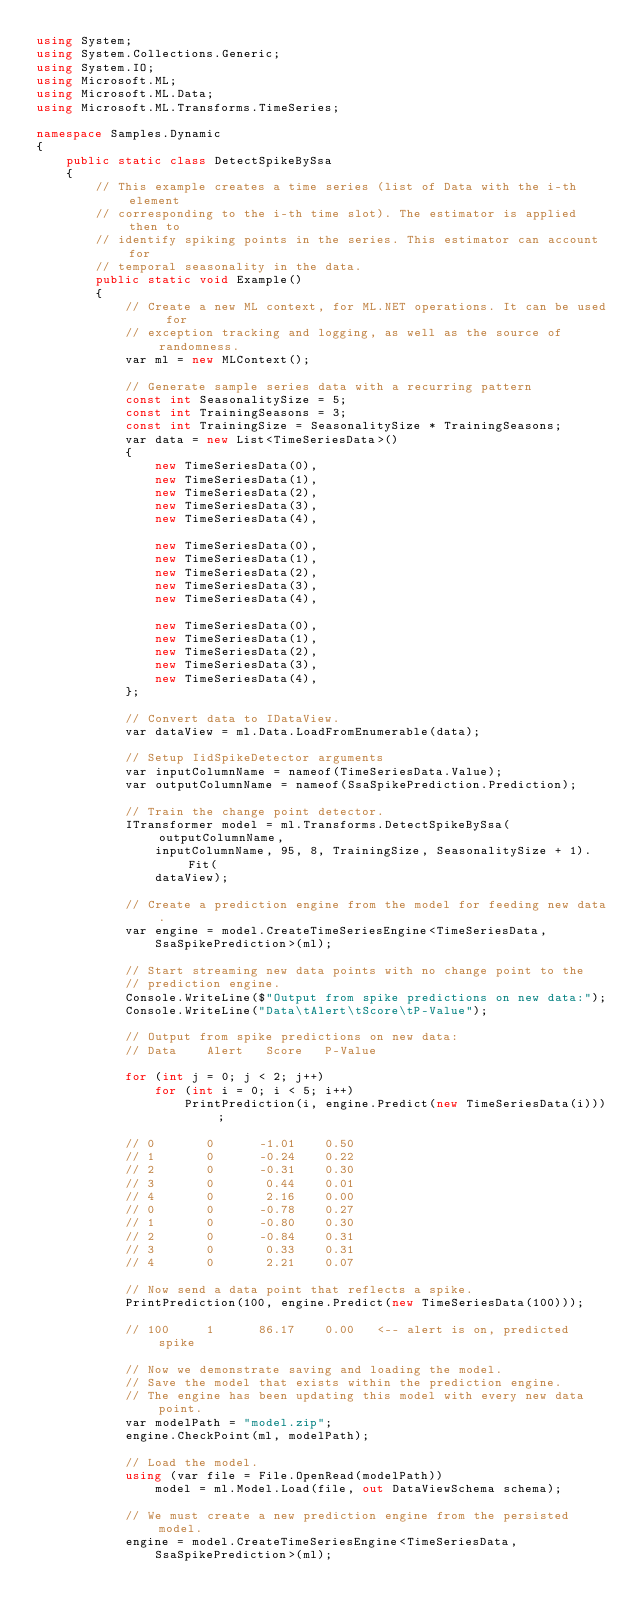<code> <loc_0><loc_0><loc_500><loc_500><_C#_>using System;
using System.Collections.Generic;
using System.IO;
using Microsoft.ML;
using Microsoft.ML.Data;
using Microsoft.ML.Transforms.TimeSeries;

namespace Samples.Dynamic
{
    public static class DetectSpikeBySsa
    {
        // This example creates a time series (list of Data with the i-th element
        // corresponding to the i-th time slot). The estimator is applied then to
        // identify spiking points in the series. This estimator can account for
        // temporal seasonality in the data.
        public static void Example()
        {
            // Create a new ML context, for ML.NET operations. It can be used for
            // exception tracking and logging, as well as the source of randomness.
            var ml = new MLContext();

            // Generate sample series data with a recurring pattern
            const int SeasonalitySize = 5;
            const int TrainingSeasons = 3;
            const int TrainingSize = SeasonalitySize * TrainingSeasons;
            var data = new List<TimeSeriesData>()
            {
                new TimeSeriesData(0),
                new TimeSeriesData(1),
                new TimeSeriesData(2),
                new TimeSeriesData(3),
                new TimeSeriesData(4),

                new TimeSeriesData(0),
                new TimeSeriesData(1),
                new TimeSeriesData(2),
                new TimeSeriesData(3),
                new TimeSeriesData(4),

                new TimeSeriesData(0),
                new TimeSeriesData(1),
                new TimeSeriesData(2),
                new TimeSeriesData(3),
                new TimeSeriesData(4),
            };

            // Convert data to IDataView.
            var dataView = ml.Data.LoadFromEnumerable(data);

            // Setup IidSpikeDetector arguments
            var inputColumnName = nameof(TimeSeriesData.Value);
            var outputColumnName = nameof(SsaSpikePrediction.Prediction);

            // Train the change point detector.
            ITransformer model = ml.Transforms.DetectSpikeBySsa(outputColumnName,
                inputColumnName, 95, 8, TrainingSize, SeasonalitySize + 1).Fit(
                dataView);

            // Create a prediction engine from the model for feeding new data.
            var engine = model.CreateTimeSeriesEngine<TimeSeriesData,
                SsaSpikePrediction>(ml);

            // Start streaming new data points with no change point to the
            // prediction engine.
            Console.WriteLine($"Output from spike predictions on new data:");
            Console.WriteLine("Data\tAlert\tScore\tP-Value");

            // Output from spike predictions on new data:
            // Data    Alert   Score   P-Value

            for (int j = 0; j < 2; j++)
                for (int i = 0; i < 5; i++)
                    PrintPrediction(i, engine.Predict(new TimeSeriesData(i)));

            // 0       0      -1.01    0.50
            // 1       0      -0.24    0.22
            // 2       0      -0.31    0.30
            // 3       0       0.44    0.01
            // 4       0       2.16    0.00
            // 0       0      -0.78    0.27
            // 1       0      -0.80    0.30
            // 2       0      -0.84    0.31
            // 3       0       0.33    0.31
            // 4       0       2.21    0.07

            // Now send a data point that reflects a spike.
            PrintPrediction(100, engine.Predict(new TimeSeriesData(100)));

            // 100     1      86.17    0.00   <-- alert is on, predicted spike

            // Now we demonstrate saving and loading the model.
            // Save the model that exists within the prediction engine.
            // The engine has been updating this model with every new data point.
            var modelPath = "model.zip";
            engine.CheckPoint(ml, modelPath);

            // Load the model.
            using (var file = File.OpenRead(modelPath))
                model = ml.Model.Load(file, out DataViewSchema schema);

            // We must create a new prediction engine from the persisted model.
            engine = model.CreateTimeSeriesEngine<TimeSeriesData,
                SsaSpikePrediction>(ml);
</code> 